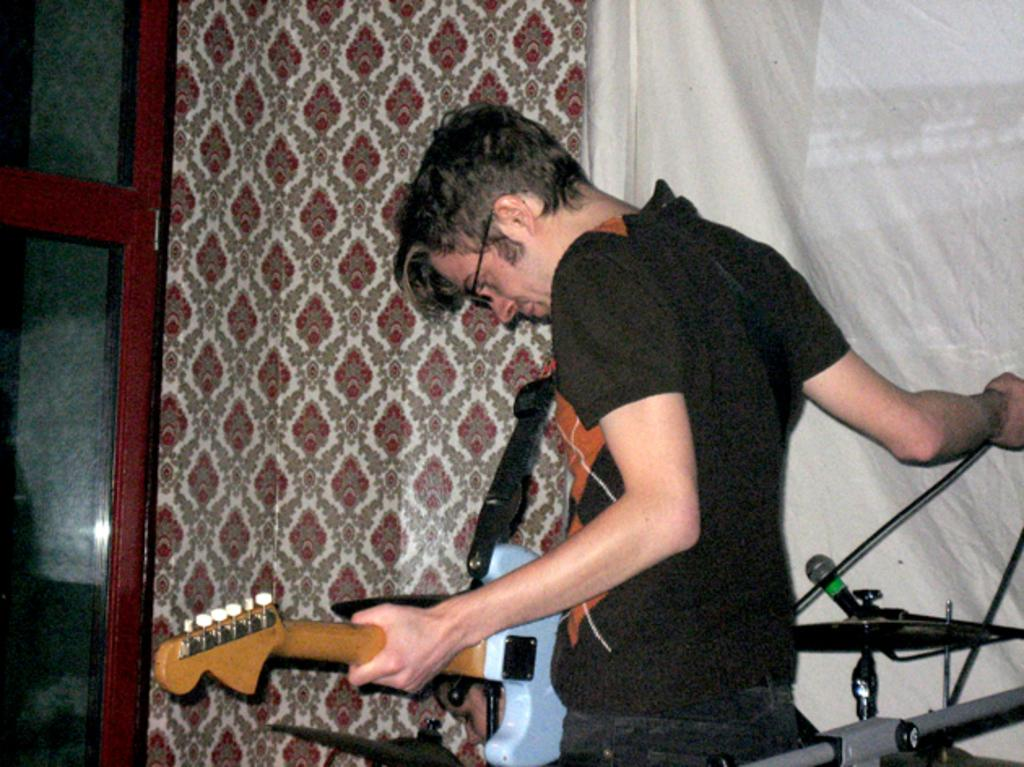What is the man in the image holding? The man is holding a guitar in the image. What other object is present in the image that is commonly used for amplifying sound? There is a microphone in the image. What other musical instruments can be seen in the image? There are other musical instruments in the image. What can be seen in the background of the image? Clothes are visible in the background of the image. Can you see a squirrel playing with the guitar in the image? No, there is no squirrel present in the image. Is this a family gathering, as seen in the image? The image does not provide any information about a family gathering; it only shows a man holding a guitar and other musical instruments. 